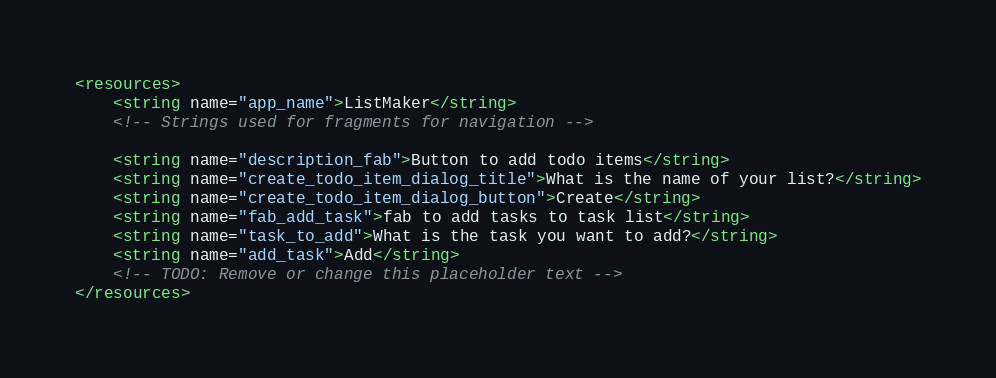<code> <loc_0><loc_0><loc_500><loc_500><_XML_><resources>
    <string name="app_name">ListMaker</string>
    <!-- Strings used for fragments for navigation -->

    <string name="description_fab">Button to add todo items</string>
    <string name="create_todo_item_dialog_title">What is the name of your list?</string>
    <string name="create_todo_item_dialog_button">Create</string>
    <string name="fab_add_task">fab to add tasks to task list</string>
    <string name="task_to_add">What is the task you want to add?</string>
    <string name="add_task">Add</string>
    <!-- TODO: Remove or change this placeholder text -->
</resources></code> 